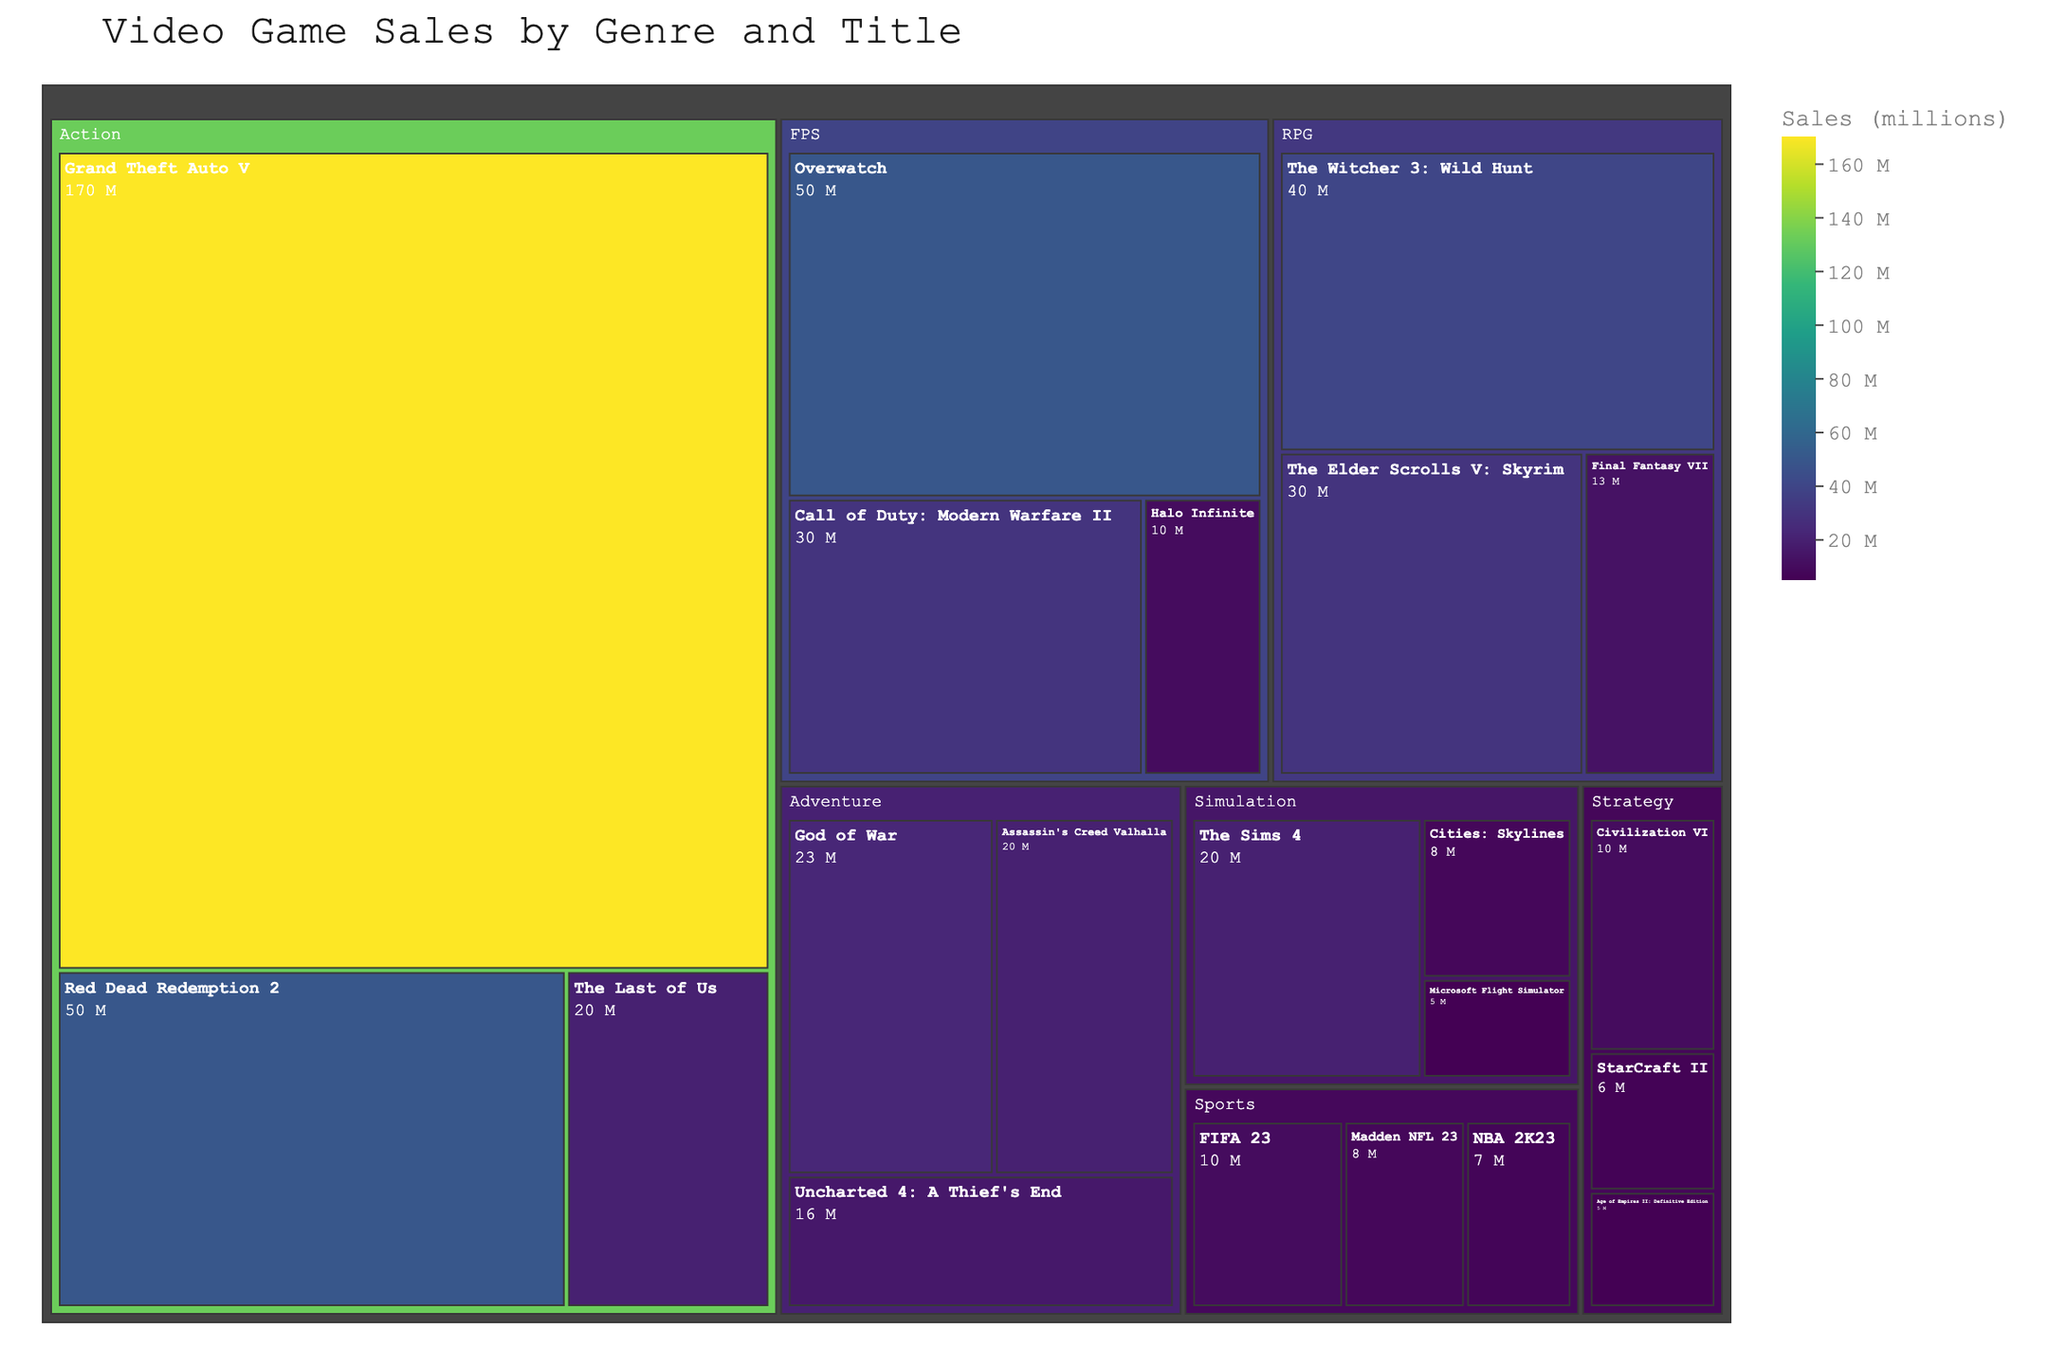What is the total sales of Action genre games? The Action genre games listed are Grand Theft Auto V (170 million), Red Dead Redemption 2 (50 million), and The Last of Us (20 million). Summing these values gives a total sales figure of 170 + 50 + 20 = 240 million.
Answer: 240 million Which genre has the highest-selling game title, and what is its sales figure? The highest-selling game title in the treemap is Grand Theft Auto V under the Action genre with 170 million in sales.
Answer: Action, 170 million What is the combined sales figure for the top-selling titles in the FPS genre? The FPS genre includes Call of Duty: Modern Warfare II (30 million), Overwatch (50 million), and Halo Infinite (10 million). Summing these values gives a total of 30 + 50 + 10 = 90 million.
Answer: 90 million Which genre has more total sales, RPG or Sports? RPG genre has The Elder Scrolls V: Skyrim (30 million), The Witcher 3: Wild Hunt (40 million), and Final Fantasy VII (13 million), giving a total of 30 + 40 + 13 = 83 million. The Sports genre has FIFA 23 (10 million), Madden NFL 23 (8 million), and NBA 2K23 (7 million), giving a total of 10 + 8 + 7 = 25 million. Comparing the totals, RPG (83 million) has more total sales than Sports (25 million).
Answer: RPG How many titles in total are listed under the Strategy genre? The Strategy genre includes Civilization VI, Age of Empires II: Definitive Edition, and StarCraft II. Counting these titles gives a total of 3 titles.
Answer: 3 Which genre has the lowest top-selling title in terms of sales, and what is the sales figure for that title? The lowest top-selling title is found by identifying the genre with the game having the smallest maximum sales. Simulation has the top title as The Sims 4 with 20 million. Comparing with other genres, Strategy has Civilization VI at 10 million. Thus, Strategy with Civilization VI at 10 million has the lowest top-selling title.
Answer: Strategy, 10 million What is the average sales figure for the games listed under the Adventure genre? The Adventure genre includes Assassin's Creed Valhalla (20 million), Uncharted 4: A Thief's End (16 million), and God of War (23 million). Summing these values gives 20 + 16 + 23 = 59 million. There are 3 games, so the average sales figure is 59 / 3 = 19.67 million.
Answer: 19.67 million Which genre has the smallest total sales, and what is the sales figure? Calculate the total sales for each genre as done previously. Strategy (21 million) has the smallest total sales when compared to all other genres.
Answer: Strategy, 21 million 